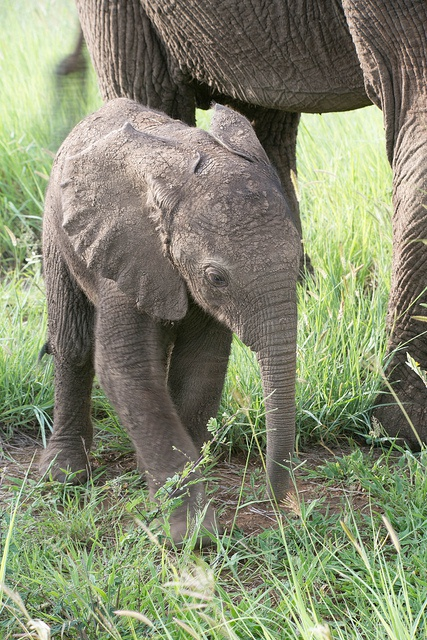Describe the objects in this image and their specific colors. I can see elephant in beige, gray, darkgray, and black tones and elephant in beige, gray, and black tones in this image. 